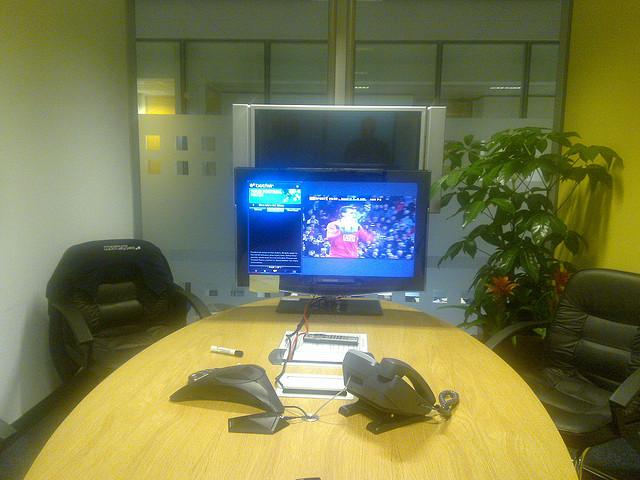Is there a sound station on the desk?
Write a very short answer. Yes. Where is the marker?
Be succinct. On table. Is anyone sitting at the desk?
Be succinct. No. 